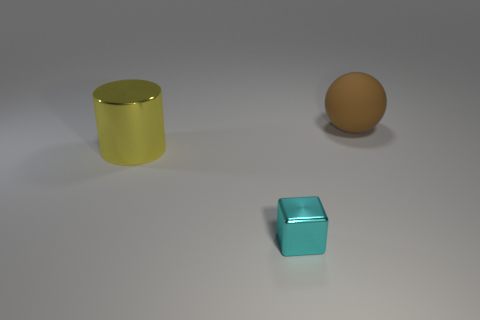Add 3 brown rubber balls. How many objects exist? 6 Subtract all balls. How many objects are left? 2 Add 1 large cyan matte cubes. How many large cyan matte cubes exist? 1 Subtract 1 yellow cylinders. How many objects are left? 2 Subtract all brown things. Subtract all yellow metal cylinders. How many objects are left? 1 Add 2 metallic things. How many metallic things are left? 4 